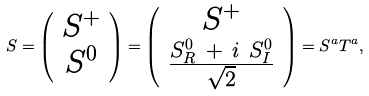<formula> <loc_0><loc_0><loc_500><loc_500>S = \left ( \begin{array} { c } S ^ { + } \\ S ^ { 0 } \end{array} \right ) = \left ( \begin{array} { c } S ^ { + } \\ \frac { S _ { R } ^ { 0 } \ + \ i \ S _ { I } ^ { 0 } } { \sqrt { 2 } } \end{array} \right ) = S ^ { a } T ^ { a } ,</formula> 